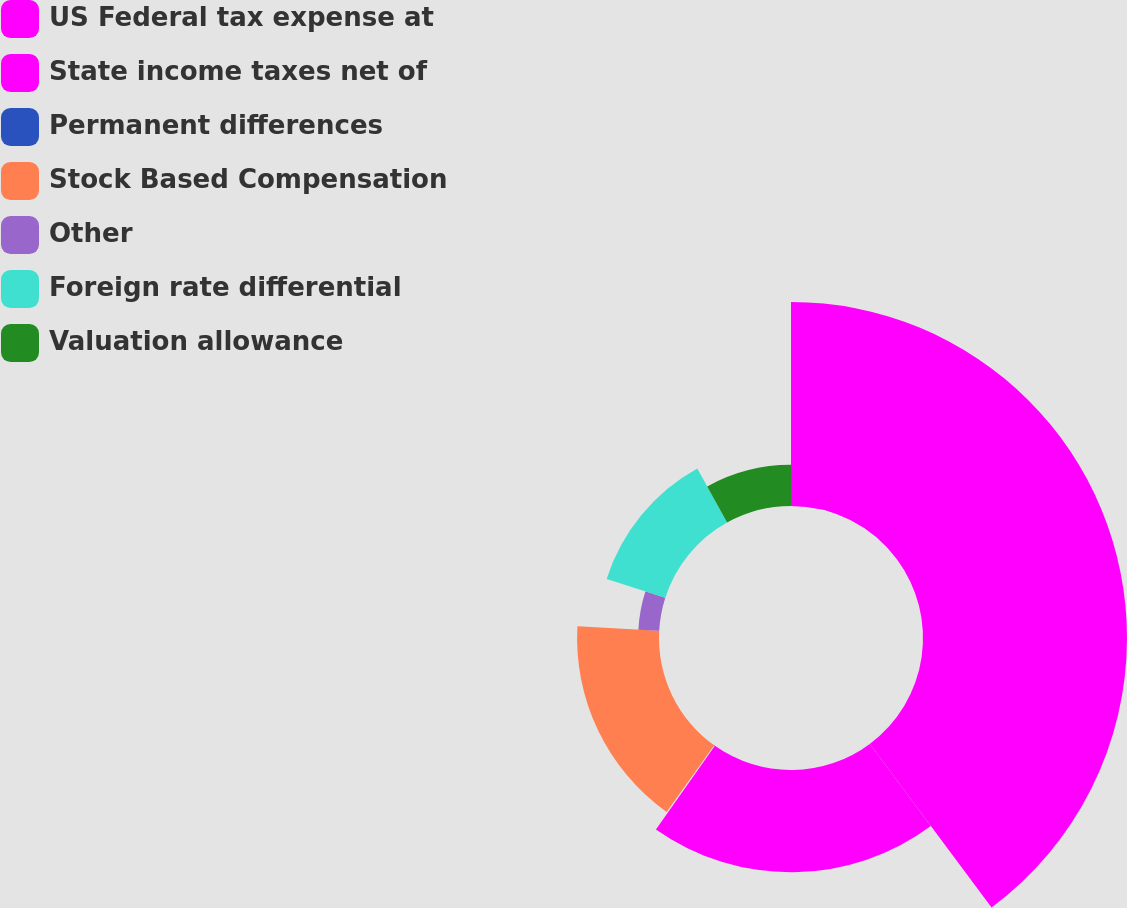Convert chart to OTSL. <chart><loc_0><loc_0><loc_500><loc_500><pie_chart><fcel>US Federal tax expense at<fcel>State income taxes net of<fcel>Permanent differences<fcel>Stock Based Compensation<fcel>Other<fcel>Foreign rate differential<fcel>Valuation allowance<nl><fcel>39.82%<fcel>19.96%<fcel>0.1%<fcel>15.99%<fcel>4.07%<fcel>12.02%<fcel>8.04%<nl></chart> 